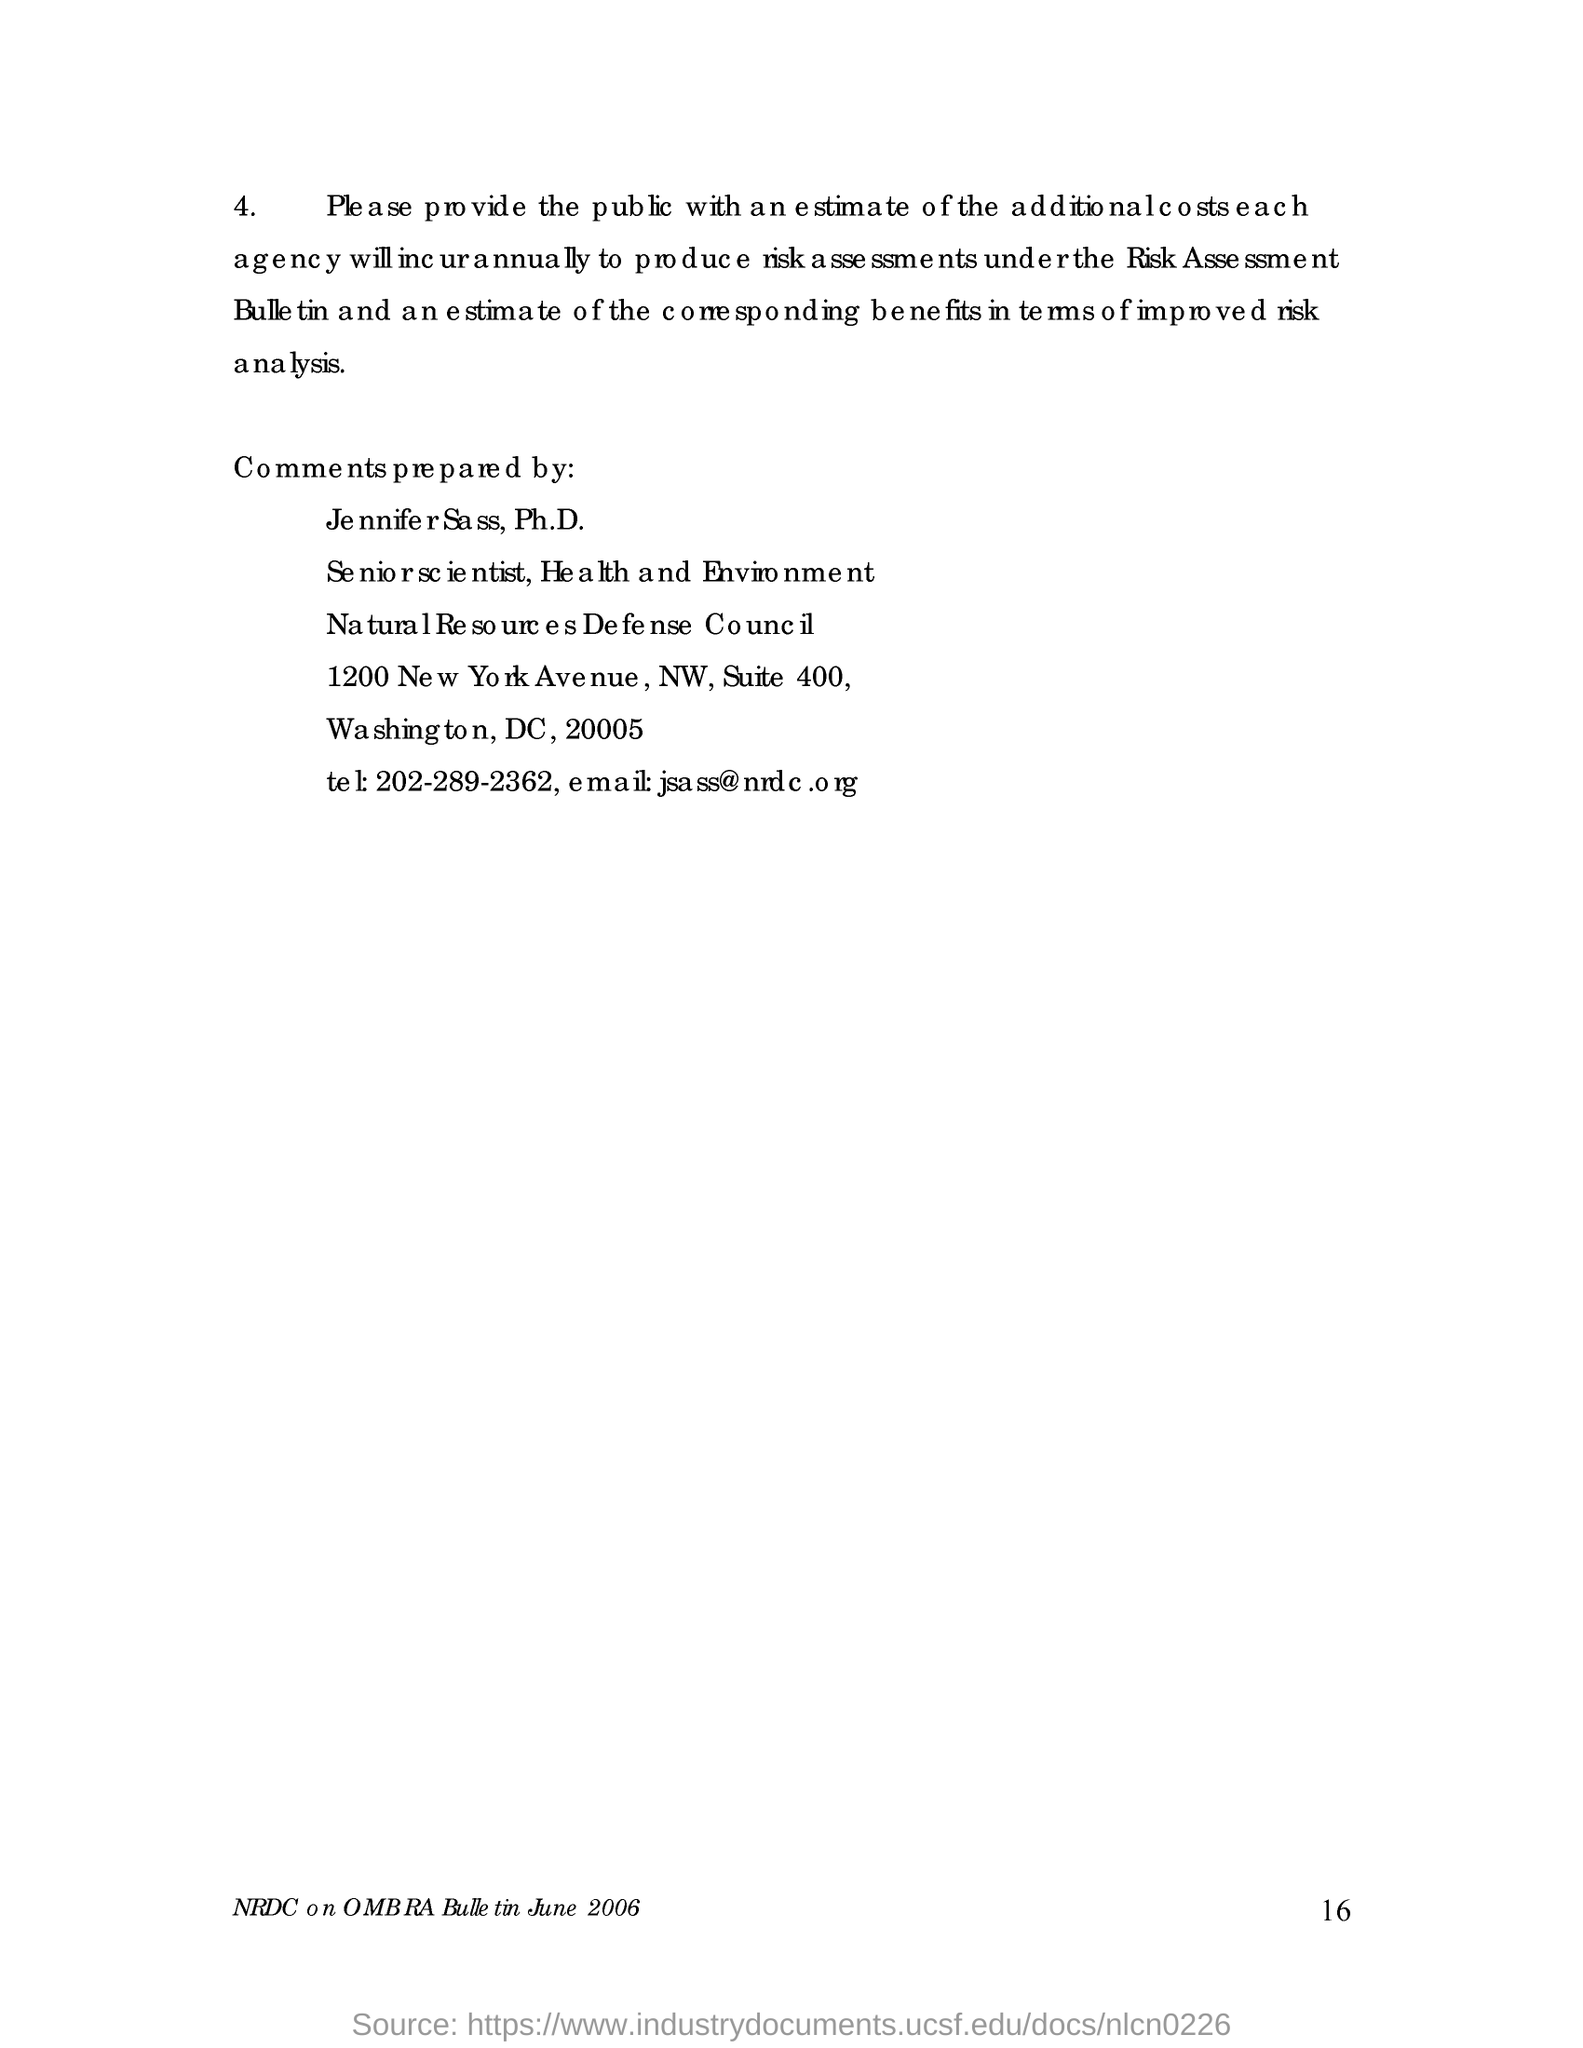Give some essential details in this illustration. The document mentions a date of June 2006. The page number mentioned in this document is 16. The comments for this document were prepared by Jennifer Sass and Jennifer Sass. The Natura Loquax Council, also known as the New Resolutions Defense Council, is a governing body responsible for maintaining order and enforcing laws in the land of Defense. 